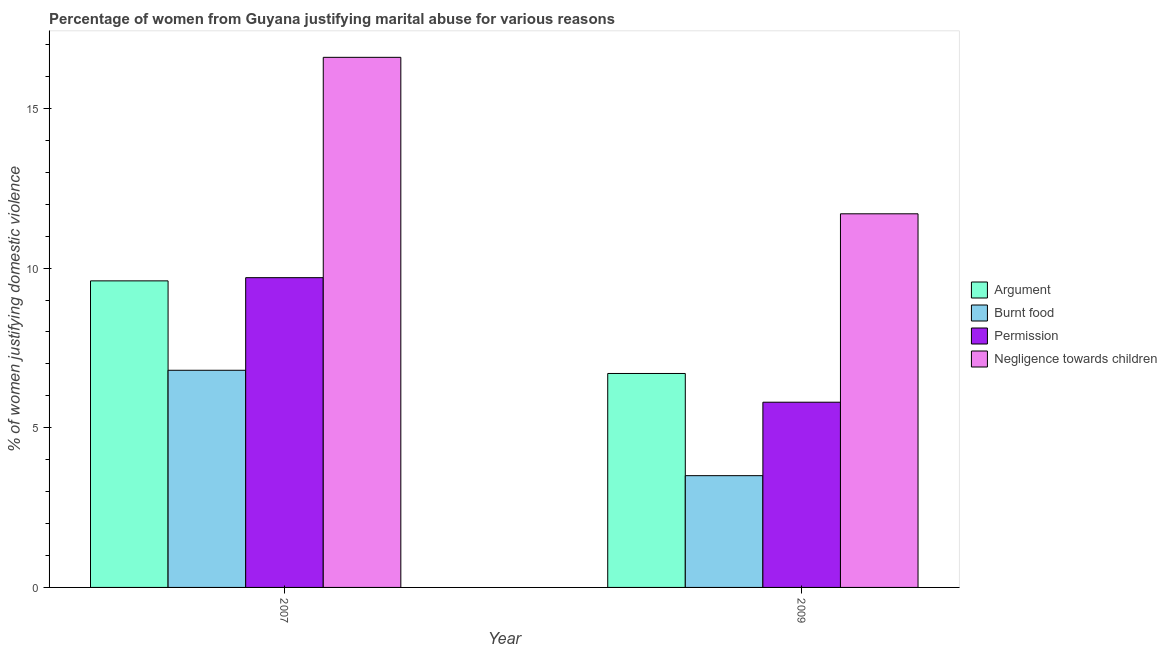How many different coloured bars are there?
Your answer should be compact. 4. Are the number of bars per tick equal to the number of legend labels?
Ensure brevity in your answer.  Yes. What is the label of the 2nd group of bars from the left?
Your answer should be compact. 2009. In how many cases, is the number of bars for a given year not equal to the number of legend labels?
Give a very brief answer. 0. What is the percentage of women justifying abuse for showing negligence towards children in 2009?
Offer a very short reply. 11.7. In which year was the percentage of women justifying abuse for going without permission minimum?
Your response must be concise. 2009. What is the total percentage of women justifying abuse for showing negligence towards children in the graph?
Keep it short and to the point. 28.3. What is the difference between the percentage of women justifying abuse in the case of an argument in 2007 and that in 2009?
Provide a short and direct response. 2.9. What is the difference between the percentage of women justifying abuse for showing negligence towards children in 2009 and the percentage of women justifying abuse for going without permission in 2007?
Your answer should be compact. -4.9. What is the average percentage of women justifying abuse in the case of an argument per year?
Your response must be concise. 8.15. In the year 2007, what is the difference between the percentage of women justifying abuse in the case of an argument and percentage of women justifying abuse for showing negligence towards children?
Provide a short and direct response. 0. In how many years, is the percentage of women justifying abuse for burning food greater than 2 %?
Your answer should be compact. 2. What is the ratio of the percentage of women justifying abuse for going without permission in 2007 to that in 2009?
Your answer should be compact. 1.67. Is the percentage of women justifying abuse for going without permission in 2007 less than that in 2009?
Your answer should be very brief. No. In how many years, is the percentage of women justifying abuse for burning food greater than the average percentage of women justifying abuse for burning food taken over all years?
Ensure brevity in your answer.  1. Is it the case that in every year, the sum of the percentage of women justifying abuse for going without permission and percentage of women justifying abuse for burning food is greater than the sum of percentage of women justifying abuse in the case of an argument and percentage of women justifying abuse for showing negligence towards children?
Your answer should be compact. No. What does the 3rd bar from the left in 2007 represents?
Keep it short and to the point. Permission. What does the 1st bar from the right in 2007 represents?
Make the answer very short. Negligence towards children. How many bars are there?
Provide a short and direct response. 8. Are all the bars in the graph horizontal?
Provide a succinct answer. No. How many years are there in the graph?
Provide a succinct answer. 2. What is the difference between two consecutive major ticks on the Y-axis?
Your answer should be compact. 5. How many legend labels are there?
Provide a succinct answer. 4. How are the legend labels stacked?
Provide a succinct answer. Vertical. What is the title of the graph?
Your response must be concise. Percentage of women from Guyana justifying marital abuse for various reasons. Does "Taxes on goods and services" appear as one of the legend labels in the graph?
Make the answer very short. No. What is the label or title of the X-axis?
Give a very brief answer. Year. What is the label or title of the Y-axis?
Offer a very short reply. % of women justifying domestic violence. What is the % of women justifying domestic violence in Argument in 2007?
Your answer should be very brief. 9.6. What is the % of women justifying domestic violence in Negligence towards children in 2007?
Your response must be concise. 16.6. What is the % of women justifying domestic violence of Permission in 2009?
Your response must be concise. 5.8. Across all years, what is the maximum % of women justifying domestic violence in Argument?
Make the answer very short. 9.6. Across all years, what is the minimum % of women justifying domestic violence in Argument?
Make the answer very short. 6.7. Across all years, what is the minimum % of women justifying domestic violence of Burnt food?
Provide a succinct answer. 3.5. Across all years, what is the minimum % of women justifying domestic violence in Permission?
Make the answer very short. 5.8. What is the total % of women justifying domestic violence of Argument in the graph?
Your response must be concise. 16.3. What is the total % of women justifying domestic violence of Burnt food in the graph?
Your response must be concise. 10.3. What is the total % of women justifying domestic violence of Negligence towards children in the graph?
Provide a succinct answer. 28.3. What is the difference between the % of women justifying domestic violence of Argument in 2007 and that in 2009?
Offer a very short reply. 2.9. What is the difference between the % of women justifying domestic violence in Burnt food in 2007 and that in 2009?
Ensure brevity in your answer.  3.3. What is the average % of women justifying domestic violence in Argument per year?
Provide a succinct answer. 8.15. What is the average % of women justifying domestic violence of Burnt food per year?
Offer a terse response. 5.15. What is the average % of women justifying domestic violence in Permission per year?
Offer a terse response. 7.75. What is the average % of women justifying domestic violence of Negligence towards children per year?
Your answer should be compact. 14.15. In the year 2007, what is the difference between the % of women justifying domestic violence of Argument and % of women justifying domestic violence of Burnt food?
Give a very brief answer. 2.8. In the year 2007, what is the difference between the % of women justifying domestic violence in Argument and % of women justifying domestic violence in Permission?
Offer a very short reply. -0.1. In the year 2007, what is the difference between the % of women justifying domestic violence of Burnt food and % of women justifying domestic violence of Negligence towards children?
Your answer should be very brief. -9.8. In the year 2007, what is the difference between the % of women justifying domestic violence in Permission and % of women justifying domestic violence in Negligence towards children?
Give a very brief answer. -6.9. In the year 2009, what is the difference between the % of women justifying domestic violence of Burnt food and % of women justifying domestic violence of Negligence towards children?
Your response must be concise. -8.2. In the year 2009, what is the difference between the % of women justifying domestic violence of Permission and % of women justifying domestic violence of Negligence towards children?
Offer a terse response. -5.9. What is the ratio of the % of women justifying domestic violence in Argument in 2007 to that in 2009?
Your response must be concise. 1.43. What is the ratio of the % of women justifying domestic violence in Burnt food in 2007 to that in 2009?
Ensure brevity in your answer.  1.94. What is the ratio of the % of women justifying domestic violence of Permission in 2007 to that in 2009?
Provide a short and direct response. 1.67. What is the ratio of the % of women justifying domestic violence in Negligence towards children in 2007 to that in 2009?
Ensure brevity in your answer.  1.42. What is the difference between the highest and the second highest % of women justifying domestic violence in Argument?
Provide a succinct answer. 2.9. What is the difference between the highest and the second highest % of women justifying domestic violence in Permission?
Keep it short and to the point. 3.9. What is the difference between the highest and the lowest % of women justifying domestic violence of Argument?
Offer a very short reply. 2.9. What is the difference between the highest and the lowest % of women justifying domestic violence of Negligence towards children?
Keep it short and to the point. 4.9. 